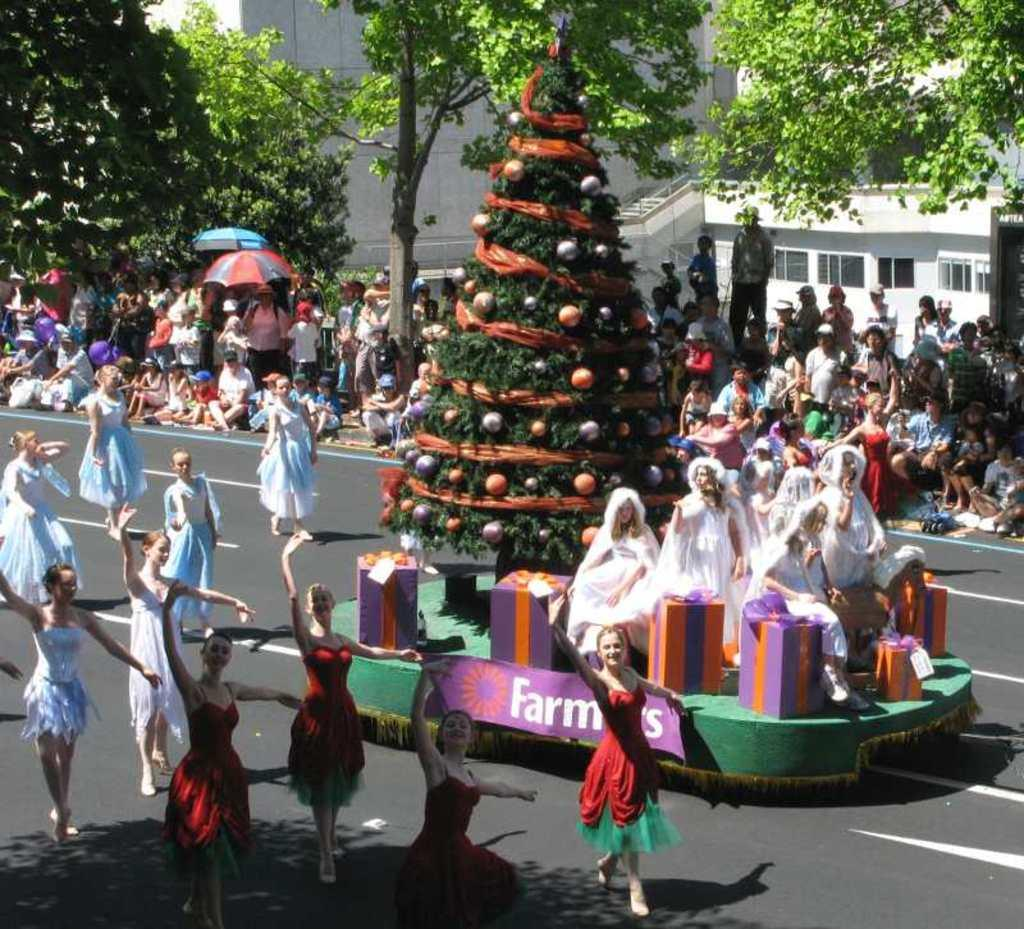What is the main feature of the image? There is a road in the image. What activity is taking place in the image? There are people dancing in the image. Are there any holiday decorations in the image? Yes, there is a Christmas tree in the image. What type of natural elements can be seen in the image? There are trees in the image. What type of man-made structures are present in the image? There are buildings in the image. Who is watching the dancing people in the image? There is an audience in the image. What type of engine can be seen powering the dancing people in the image? There is no engine present in the image, and the people are dancing without any mechanical assistance. What type of meal is being served to the audience in the image? There is no meal being served in the image; the focus is on the dancing people and the audience watching them. 